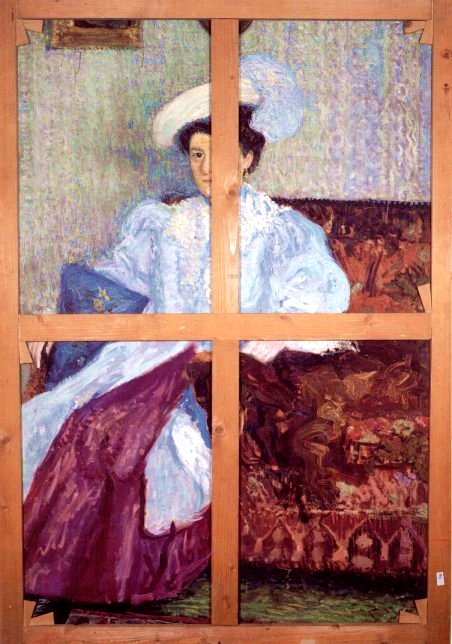What's happening in the scene? This image is a beautiful piece of impressionist art consisting of four separate yet interconnected panels created by wooden beams. Each panel reveals different elements of a mysterious and serene scene. In the top left, the face and upper body of a woman are depicted, her expression serene and thoughtful. The top right panel shows an elegantly designed white hat, creating a stunning contrast with the vibrancy of the rest of the painting. The bottom left panel captures a flowing blue dress paired with a purple skirt, adding layers of color and depth. Finally, the bottom right showcases a richly colored red couch that blends seamlessly with the background. The overall tranquil ambiance and the soft, vibrant brushstrokes characterize the essence of impressionism in this artwork. 